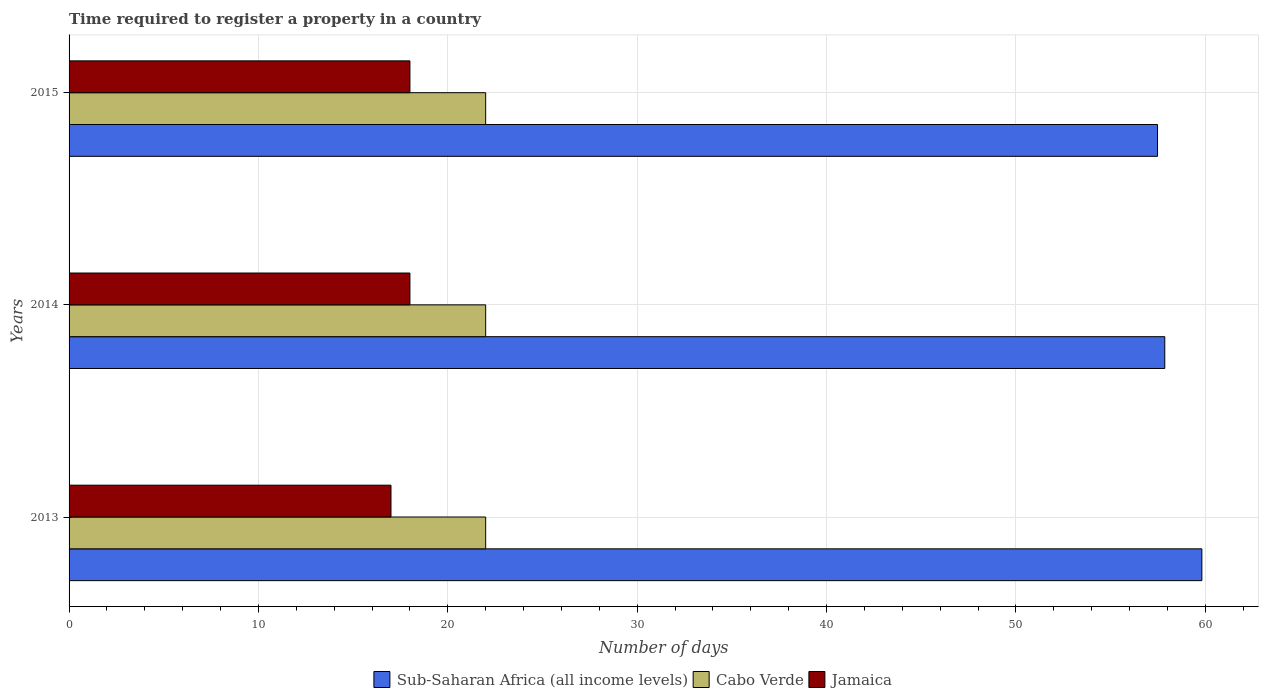How many different coloured bars are there?
Ensure brevity in your answer.  3. How many groups of bars are there?
Offer a terse response. 3. What is the label of the 1st group of bars from the top?
Your response must be concise. 2015. What is the number of days required to register a property in Cabo Verde in 2013?
Make the answer very short. 22. Across all years, what is the minimum number of days required to register a property in Cabo Verde?
Your response must be concise. 22. In which year was the number of days required to register a property in Jamaica maximum?
Your answer should be very brief. 2014. In which year was the number of days required to register a property in Sub-Saharan Africa (all income levels) minimum?
Give a very brief answer. 2015. What is the total number of days required to register a property in Jamaica in the graph?
Make the answer very short. 53. What is the difference between the number of days required to register a property in Cabo Verde in 2014 and the number of days required to register a property in Sub-Saharan Africa (all income levels) in 2013?
Keep it short and to the point. -37.82. What is the average number of days required to register a property in Cabo Verde per year?
Keep it short and to the point. 22. In the year 2015, what is the difference between the number of days required to register a property in Sub-Saharan Africa (all income levels) and number of days required to register a property in Jamaica?
Offer a very short reply. 39.48. What is the ratio of the number of days required to register a property in Sub-Saharan Africa (all income levels) in 2014 to that in 2015?
Provide a short and direct response. 1.01. Is the number of days required to register a property in Cabo Verde in 2013 less than that in 2015?
Offer a terse response. No. Is the difference between the number of days required to register a property in Sub-Saharan Africa (all income levels) in 2013 and 2014 greater than the difference between the number of days required to register a property in Jamaica in 2013 and 2014?
Your answer should be very brief. Yes. What is the difference between the highest and the second highest number of days required to register a property in Sub-Saharan Africa (all income levels)?
Give a very brief answer. 1.96. What is the difference between the highest and the lowest number of days required to register a property in Jamaica?
Offer a very short reply. 1. Is the sum of the number of days required to register a property in Cabo Verde in 2013 and 2015 greater than the maximum number of days required to register a property in Sub-Saharan Africa (all income levels) across all years?
Your answer should be very brief. No. What does the 1st bar from the top in 2013 represents?
Provide a succinct answer. Jamaica. What does the 3rd bar from the bottom in 2015 represents?
Your answer should be very brief. Jamaica. Is it the case that in every year, the sum of the number of days required to register a property in Sub-Saharan Africa (all income levels) and number of days required to register a property in Cabo Verde is greater than the number of days required to register a property in Jamaica?
Your answer should be compact. Yes. How many bars are there?
Make the answer very short. 9. Are all the bars in the graph horizontal?
Give a very brief answer. Yes. Are the values on the major ticks of X-axis written in scientific E-notation?
Provide a short and direct response. No. Does the graph contain any zero values?
Provide a succinct answer. No. How are the legend labels stacked?
Your answer should be very brief. Horizontal. What is the title of the graph?
Give a very brief answer. Time required to register a property in a country. Does "Malaysia" appear as one of the legend labels in the graph?
Your answer should be very brief. No. What is the label or title of the X-axis?
Make the answer very short. Number of days. What is the Number of days of Sub-Saharan Africa (all income levels) in 2013?
Provide a succinct answer. 59.82. What is the Number of days in Cabo Verde in 2013?
Your answer should be compact. 22. What is the Number of days in Sub-Saharan Africa (all income levels) in 2014?
Offer a very short reply. 57.86. What is the Number of days of Jamaica in 2014?
Provide a succinct answer. 18. What is the Number of days of Sub-Saharan Africa (all income levels) in 2015?
Provide a short and direct response. 57.48. Across all years, what is the maximum Number of days of Sub-Saharan Africa (all income levels)?
Your response must be concise. 59.82. Across all years, what is the maximum Number of days in Jamaica?
Keep it short and to the point. 18. Across all years, what is the minimum Number of days of Sub-Saharan Africa (all income levels)?
Provide a short and direct response. 57.48. Across all years, what is the minimum Number of days of Jamaica?
Offer a terse response. 17. What is the total Number of days of Sub-Saharan Africa (all income levels) in the graph?
Give a very brief answer. 175.17. What is the total Number of days in Jamaica in the graph?
Offer a very short reply. 53. What is the difference between the Number of days of Sub-Saharan Africa (all income levels) in 2013 and that in 2014?
Provide a short and direct response. 1.96. What is the difference between the Number of days of Cabo Verde in 2013 and that in 2014?
Your answer should be very brief. 0. What is the difference between the Number of days in Jamaica in 2013 and that in 2014?
Ensure brevity in your answer.  -1. What is the difference between the Number of days in Sub-Saharan Africa (all income levels) in 2013 and that in 2015?
Provide a succinct answer. 2.34. What is the difference between the Number of days in Sub-Saharan Africa (all income levels) in 2014 and that in 2015?
Provide a succinct answer. 0.38. What is the difference between the Number of days in Cabo Verde in 2014 and that in 2015?
Make the answer very short. 0. What is the difference between the Number of days in Jamaica in 2014 and that in 2015?
Offer a very short reply. 0. What is the difference between the Number of days of Sub-Saharan Africa (all income levels) in 2013 and the Number of days of Cabo Verde in 2014?
Keep it short and to the point. 37.82. What is the difference between the Number of days in Sub-Saharan Africa (all income levels) in 2013 and the Number of days in Jamaica in 2014?
Provide a short and direct response. 41.82. What is the difference between the Number of days in Cabo Verde in 2013 and the Number of days in Jamaica in 2014?
Provide a succinct answer. 4. What is the difference between the Number of days of Sub-Saharan Africa (all income levels) in 2013 and the Number of days of Cabo Verde in 2015?
Give a very brief answer. 37.82. What is the difference between the Number of days of Sub-Saharan Africa (all income levels) in 2013 and the Number of days of Jamaica in 2015?
Offer a very short reply. 41.82. What is the difference between the Number of days in Sub-Saharan Africa (all income levels) in 2014 and the Number of days in Cabo Verde in 2015?
Make the answer very short. 35.86. What is the difference between the Number of days of Sub-Saharan Africa (all income levels) in 2014 and the Number of days of Jamaica in 2015?
Offer a terse response. 39.86. What is the difference between the Number of days of Cabo Verde in 2014 and the Number of days of Jamaica in 2015?
Your answer should be compact. 4. What is the average Number of days in Sub-Saharan Africa (all income levels) per year?
Offer a very short reply. 58.39. What is the average Number of days of Cabo Verde per year?
Make the answer very short. 22. What is the average Number of days in Jamaica per year?
Your response must be concise. 17.67. In the year 2013, what is the difference between the Number of days in Sub-Saharan Africa (all income levels) and Number of days in Cabo Verde?
Give a very brief answer. 37.82. In the year 2013, what is the difference between the Number of days in Sub-Saharan Africa (all income levels) and Number of days in Jamaica?
Your answer should be very brief. 42.82. In the year 2013, what is the difference between the Number of days in Cabo Verde and Number of days in Jamaica?
Ensure brevity in your answer.  5. In the year 2014, what is the difference between the Number of days of Sub-Saharan Africa (all income levels) and Number of days of Cabo Verde?
Provide a short and direct response. 35.86. In the year 2014, what is the difference between the Number of days in Sub-Saharan Africa (all income levels) and Number of days in Jamaica?
Ensure brevity in your answer.  39.86. In the year 2014, what is the difference between the Number of days of Cabo Verde and Number of days of Jamaica?
Keep it short and to the point. 4. In the year 2015, what is the difference between the Number of days of Sub-Saharan Africa (all income levels) and Number of days of Cabo Verde?
Offer a very short reply. 35.48. In the year 2015, what is the difference between the Number of days in Sub-Saharan Africa (all income levels) and Number of days in Jamaica?
Your response must be concise. 39.48. In the year 2015, what is the difference between the Number of days in Cabo Verde and Number of days in Jamaica?
Provide a short and direct response. 4. What is the ratio of the Number of days in Sub-Saharan Africa (all income levels) in 2013 to that in 2014?
Offer a terse response. 1.03. What is the ratio of the Number of days in Cabo Verde in 2013 to that in 2014?
Provide a succinct answer. 1. What is the ratio of the Number of days of Sub-Saharan Africa (all income levels) in 2013 to that in 2015?
Offer a terse response. 1.04. What is the ratio of the Number of days of Cabo Verde in 2013 to that in 2015?
Give a very brief answer. 1. What is the ratio of the Number of days in Jamaica in 2013 to that in 2015?
Your response must be concise. 0.94. What is the ratio of the Number of days of Sub-Saharan Africa (all income levels) in 2014 to that in 2015?
Provide a short and direct response. 1.01. What is the difference between the highest and the second highest Number of days in Sub-Saharan Africa (all income levels)?
Offer a very short reply. 1.96. What is the difference between the highest and the second highest Number of days in Jamaica?
Your answer should be very brief. 0. What is the difference between the highest and the lowest Number of days in Sub-Saharan Africa (all income levels)?
Ensure brevity in your answer.  2.34. What is the difference between the highest and the lowest Number of days of Cabo Verde?
Your response must be concise. 0. What is the difference between the highest and the lowest Number of days of Jamaica?
Your response must be concise. 1. 